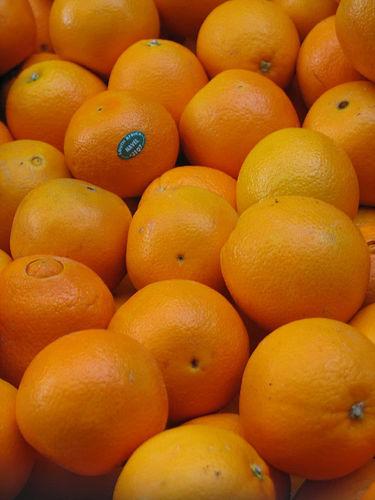Where is it on the orange that tells you how it was grown?
Quick response, please. Sticker. Were these orange's just harvested from a tree?
Be succinct. No. Do some of the oranges have leaves on them?
Give a very brief answer. No. Are all of the fruits the same kind?
Keep it brief. Yes. How many oranges have a sticker on it?
Quick response, please. 1. Are apples in this picture?
Quick response, please. No. 